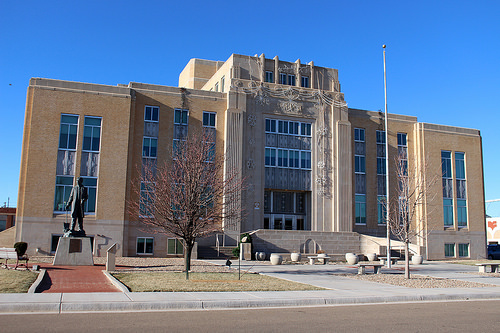<image>
Is the street under the building? No. The street is not positioned under the building. The vertical relationship between these objects is different. 